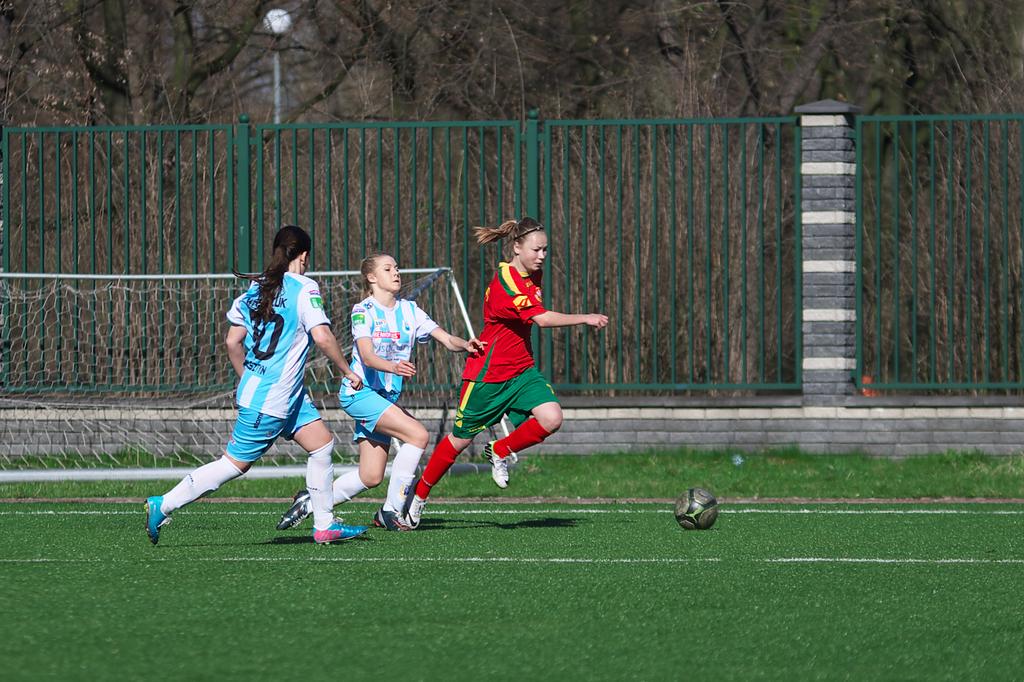What player number is the player on the left?
Provide a succinct answer. 10. 